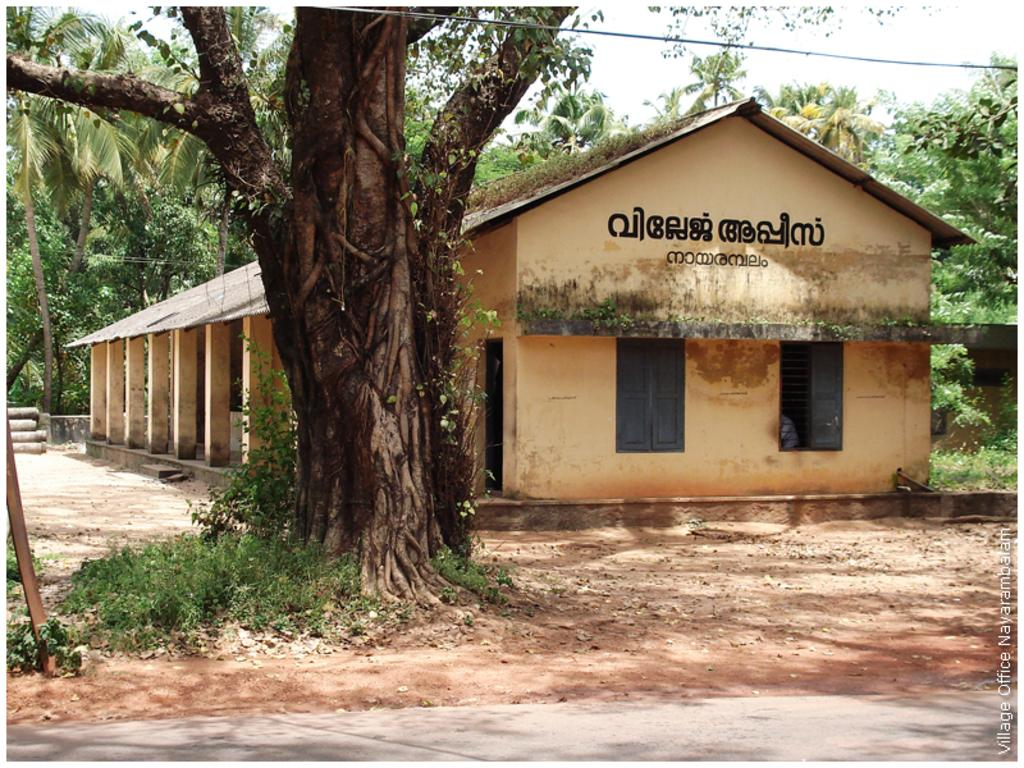What type of structure is visible in the image? There is a house in the image. What is located in front of the house? There is a path in front of the house. What else can be seen in the image besides the house and path? Cables are present in the image. What is visible behind the house? There are trees behind the house. What is visible at the top of the image? The sky is visible in the image. Can you tell me how many quince are hanging from the trees behind the house? There is no mention of quince in the image, and therefore it is not possible to determine how many are hanging from the trees. 